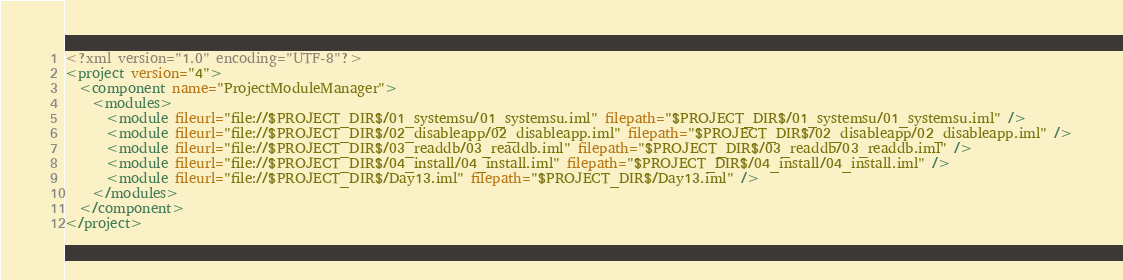Convert code to text. <code><loc_0><loc_0><loc_500><loc_500><_XML_><?xml version="1.0" encoding="UTF-8"?>
<project version="4">
  <component name="ProjectModuleManager">
    <modules>
      <module fileurl="file://$PROJECT_DIR$/01_systemsu/01_systemsu.iml" filepath="$PROJECT_DIR$/01_systemsu/01_systemsu.iml" />
      <module fileurl="file://$PROJECT_DIR$/02_disableapp/02_disableapp.iml" filepath="$PROJECT_DIR$/02_disableapp/02_disableapp.iml" />
      <module fileurl="file://$PROJECT_DIR$/03_readdb/03_readdb.iml" filepath="$PROJECT_DIR$/03_readdb/03_readdb.iml" />
      <module fileurl="file://$PROJECT_DIR$/04_install/04_install.iml" filepath="$PROJECT_DIR$/04_install/04_install.iml" />
      <module fileurl="file://$PROJECT_DIR$/Day13.iml" filepath="$PROJECT_DIR$/Day13.iml" />
    </modules>
  </component>
</project></code> 